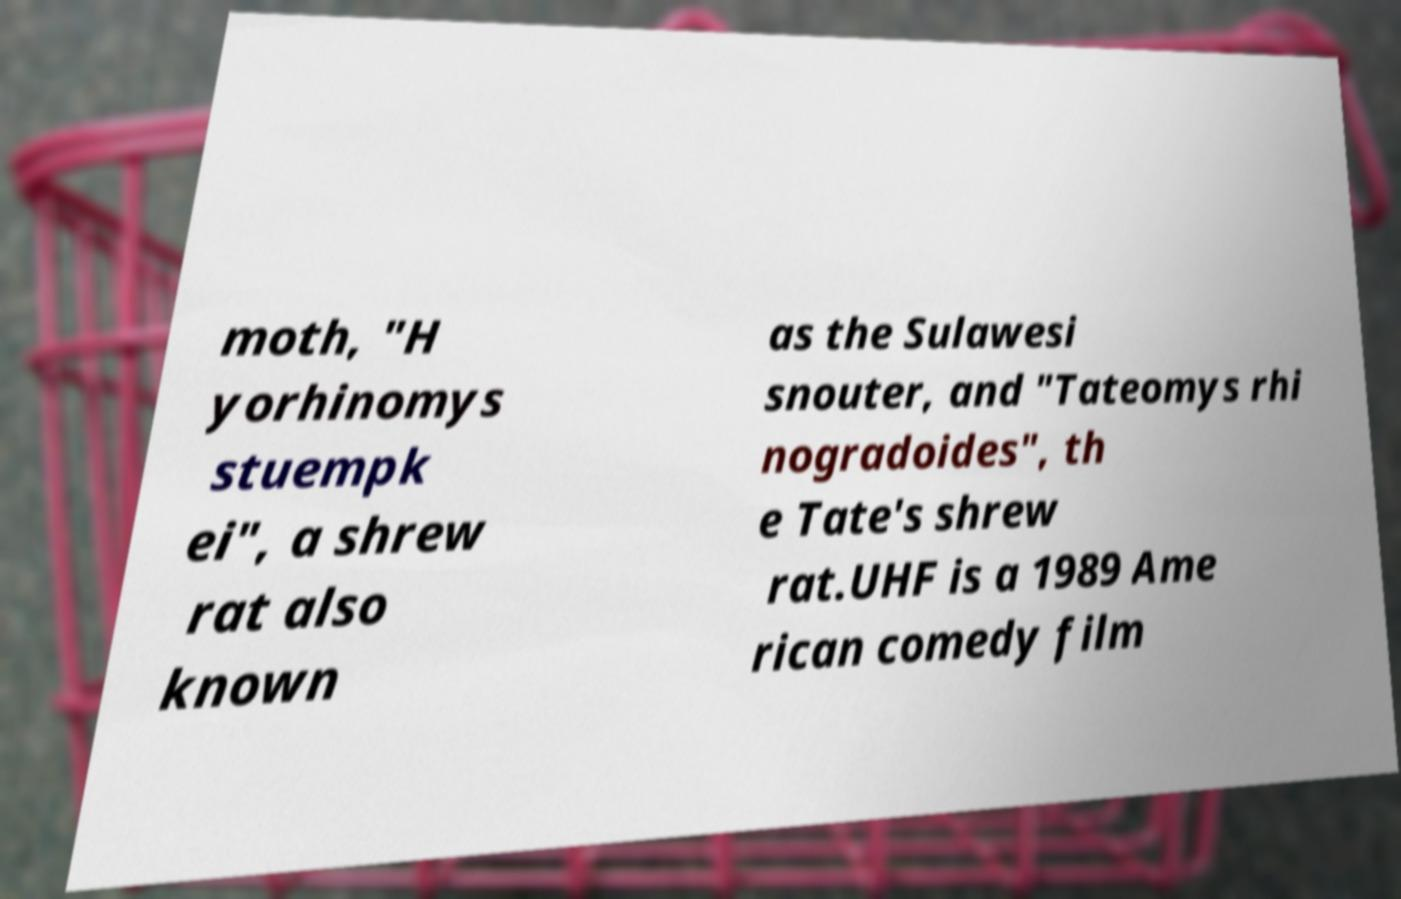Could you extract and type out the text from this image? moth, "H yorhinomys stuempk ei", a shrew rat also known as the Sulawesi snouter, and "Tateomys rhi nogradoides", th e Tate's shrew rat.UHF is a 1989 Ame rican comedy film 